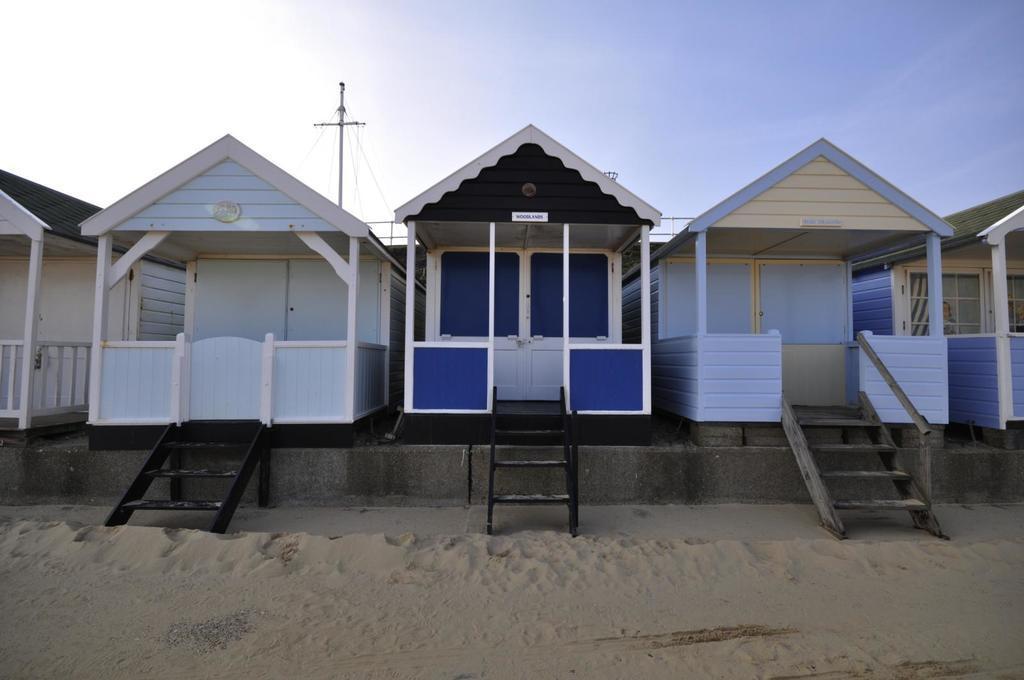How would you summarize this image in a sentence or two? In this picture, we can see a few houses, stairs, and we can see the ground, pole with wires and the sky. 